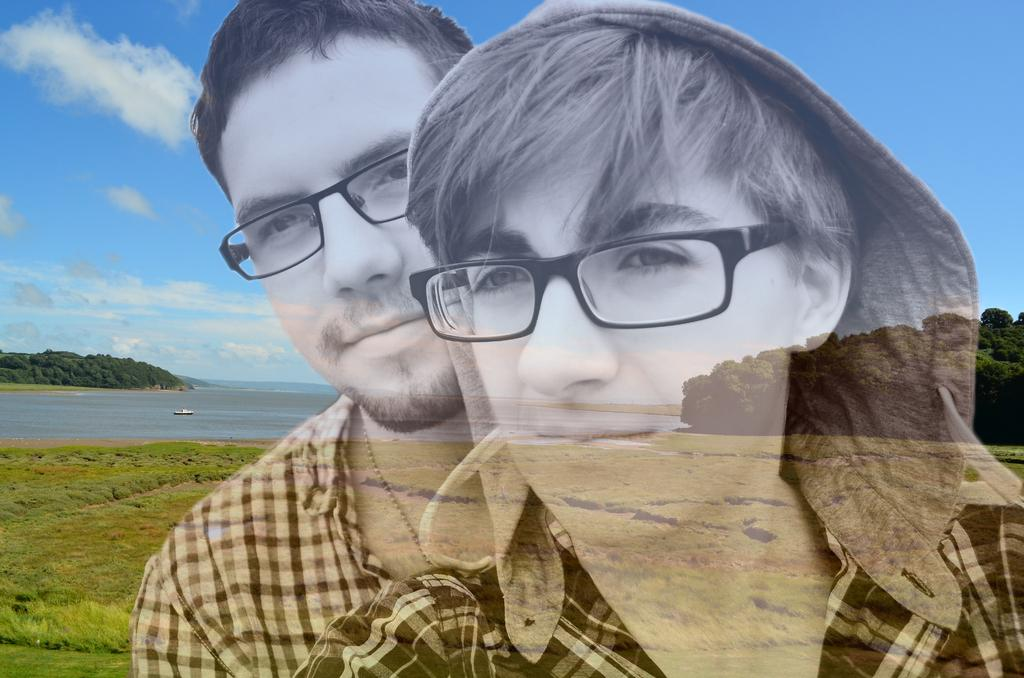How many people are in the image? There are two persons in the image. What are the persons wearing that is visible in the image? Both persons are wearing spectacles. What type of natural environment can be seen in the image? There is grass, water, and trees visible in the image. What is visible in the background of the image? The sky is visible in the background of the image, and there are clouds in the sky. What type of wire is being used to hold the cakes in the image? There are no cakes or wires present in the image. 